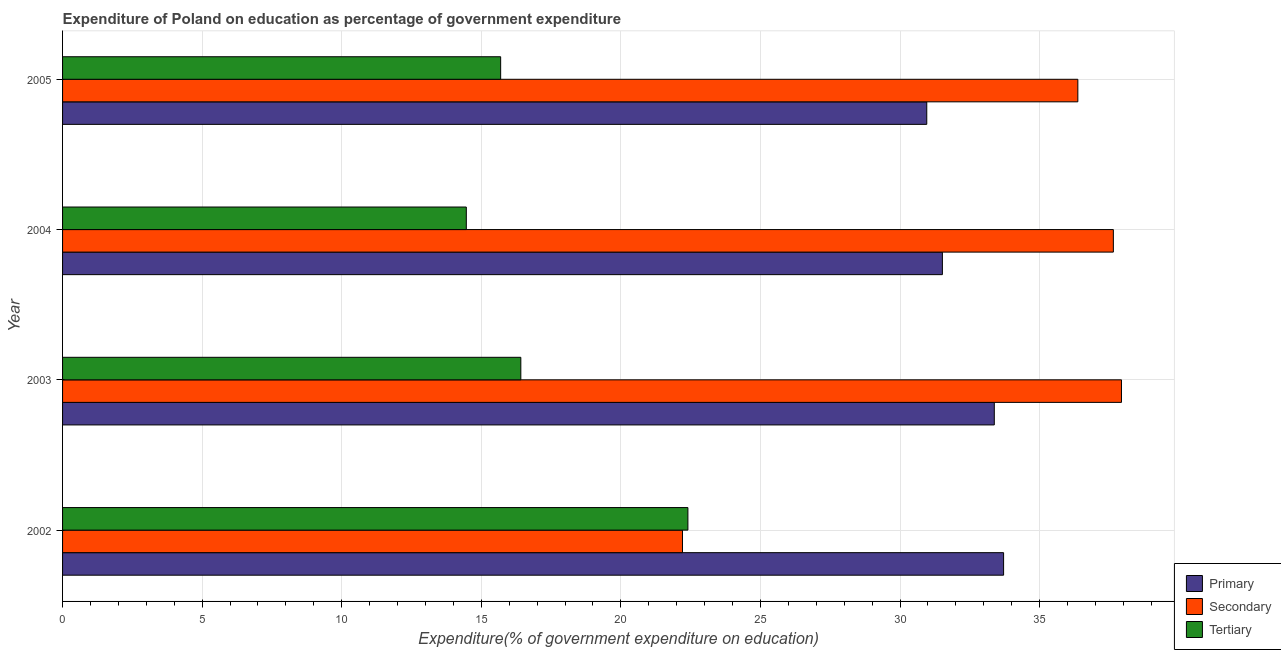How many different coloured bars are there?
Give a very brief answer. 3. How many groups of bars are there?
Ensure brevity in your answer.  4. How many bars are there on the 1st tick from the top?
Keep it short and to the point. 3. In how many cases, is the number of bars for a given year not equal to the number of legend labels?
Offer a very short reply. 0. What is the expenditure on secondary education in 2002?
Your answer should be very brief. 22.21. Across all years, what is the maximum expenditure on primary education?
Provide a short and direct response. 33.71. Across all years, what is the minimum expenditure on primary education?
Your answer should be compact. 30.96. In which year was the expenditure on primary education minimum?
Keep it short and to the point. 2005. What is the total expenditure on secondary education in the graph?
Offer a terse response. 134.15. What is the difference between the expenditure on secondary education in 2003 and that in 2004?
Give a very brief answer. 0.29. What is the difference between the expenditure on tertiary education in 2004 and the expenditure on primary education in 2005?
Your answer should be compact. -16.5. What is the average expenditure on secondary education per year?
Give a very brief answer. 33.54. In the year 2004, what is the difference between the expenditure on primary education and expenditure on tertiary education?
Keep it short and to the point. 17.05. What is the ratio of the expenditure on secondary education in 2002 to that in 2004?
Your answer should be compact. 0.59. What is the difference between the highest and the second highest expenditure on secondary education?
Provide a short and direct response. 0.29. What is the difference between the highest and the lowest expenditure on secondary education?
Provide a short and direct response. 15.73. What does the 1st bar from the top in 2002 represents?
Offer a terse response. Tertiary. What does the 3rd bar from the bottom in 2004 represents?
Keep it short and to the point. Tertiary. Is it the case that in every year, the sum of the expenditure on primary education and expenditure on secondary education is greater than the expenditure on tertiary education?
Keep it short and to the point. Yes. Are all the bars in the graph horizontal?
Provide a succinct answer. Yes. What is the difference between two consecutive major ticks on the X-axis?
Make the answer very short. 5. Does the graph contain grids?
Your answer should be very brief. Yes. Where does the legend appear in the graph?
Offer a terse response. Bottom right. How many legend labels are there?
Make the answer very short. 3. What is the title of the graph?
Your answer should be very brief. Expenditure of Poland on education as percentage of government expenditure. Does "Solid fuel" appear as one of the legend labels in the graph?
Your response must be concise. No. What is the label or title of the X-axis?
Your answer should be compact. Expenditure(% of government expenditure on education). What is the Expenditure(% of government expenditure on education) in Primary in 2002?
Your response must be concise. 33.71. What is the Expenditure(% of government expenditure on education) in Secondary in 2002?
Ensure brevity in your answer.  22.21. What is the Expenditure(% of government expenditure on education) of Tertiary in 2002?
Ensure brevity in your answer.  22.4. What is the Expenditure(% of government expenditure on education) of Primary in 2003?
Ensure brevity in your answer.  33.38. What is the Expenditure(% of government expenditure on education) of Secondary in 2003?
Keep it short and to the point. 37.93. What is the Expenditure(% of government expenditure on education) in Tertiary in 2003?
Offer a very short reply. 16.42. What is the Expenditure(% of government expenditure on education) of Primary in 2004?
Give a very brief answer. 31.52. What is the Expenditure(% of government expenditure on education) in Secondary in 2004?
Offer a terse response. 37.64. What is the Expenditure(% of government expenditure on education) of Tertiary in 2004?
Offer a very short reply. 14.46. What is the Expenditure(% of government expenditure on education) of Primary in 2005?
Make the answer very short. 30.96. What is the Expenditure(% of government expenditure on education) of Secondary in 2005?
Your answer should be very brief. 36.37. What is the Expenditure(% of government expenditure on education) in Tertiary in 2005?
Your answer should be compact. 15.69. Across all years, what is the maximum Expenditure(% of government expenditure on education) of Primary?
Provide a succinct answer. 33.71. Across all years, what is the maximum Expenditure(% of government expenditure on education) in Secondary?
Offer a terse response. 37.93. Across all years, what is the maximum Expenditure(% of government expenditure on education) of Tertiary?
Ensure brevity in your answer.  22.4. Across all years, what is the minimum Expenditure(% of government expenditure on education) in Primary?
Ensure brevity in your answer.  30.96. Across all years, what is the minimum Expenditure(% of government expenditure on education) in Secondary?
Provide a short and direct response. 22.21. Across all years, what is the minimum Expenditure(% of government expenditure on education) of Tertiary?
Ensure brevity in your answer.  14.46. What is the total Expenditure(% of government expenditure on education) in Primary in the graph?
Your response must be concise. 129.57. What is the total Expenditure(% of government expenditure on education) of Secondary in the graph?
Offer a terse response. 134.15. What is the total Expenditure(% of government expenditure on education) in Tertiary in the graph?
Your answer should be very brief. 68.98. What is the difference between the Expenditure(% of government expenditure on education) of Primary in 2002 and that in 2003?
Offer a very short reply. 0.33. What is the difference between the Expenditure(% of government expenditure on education) of Secondary in 2002 and that in 2003?
Your answer should be very brief. -15.73. What is the difference between the Expenditure(% of government expenditure on education) of Tertiary in 2002 and that in 2003?
Make the answer very short. 5.99. What is the difference between the Expenditure(% of government expenditure on education) in Primary in 2002 and that in 2004?
Your answer should be compact. 2.19. What is the difference between the Expenditure(% of government expenditure on education) of Secondary in 2002 and that in 2004?
Provide a succinct answer. -15.44. What is the difference between the Expenditure(% of government expenditure on education) of Tertiary in 2002 and that in 2004?
Provide a short and direct response. 7.94. What is the difference between the Expenditure(% of government expenditure on education) in Primary in 2002 and that in 2005?
Your answer should be very brief. 2.75. What is the difference between the Expenditure(% of government expenditure on education) in Secondary in 2002 and that in 2005?
Offer a very short reply. -14.16. What is the difference between the Expenditure(% of government expenditure on education) in Tertiary in 2002 and that in 2005?
Your answer should be very brief. 6.71. What is the difference between the Expenditure(% of government expenditure on education) in Primary in 2003 and that in 2004?
Your response must be concise. 1.86. What is the difference between the Expenditure(% of government expenditure on education) in Secondary in 2003 and that in 2004?
Ensure brevity in your answer.  0.29. What is the difference between the Expenditure(% of government expenditure on education) in Tertiary in 2003 and that in 2004?
Your response must be concise. 1.95. What is the difference between the Expenditure(% of government expenditure on education) in Primary in 2003 and that in 2005?
Keep it short and to the point. 2.42. What is the difference between the Expenditure(% of government expenditure on education) of Secondary in 2003 and that in 2005?
Provide a short and direct response. 1.56. What is the difference between the Expenditure(% of government expenditure on education) in Tertiary in 2003 and that in 2005?
Provide a short and direct response. 0.72. What is the difference between the Expenditure(% of government expenditure on education) of Primary in 2004 and that in 2005?
Ensure brevity in your answer.  0.56. What is the difference between the Expenditure(% of government expenditure on education) of Secondary in 2004 and that in 2005?
Provide a short and direct response. 1.27. What is the difference between the Expenditure(% of government expenditure on education) of Tertiary in 2004 and that in 2005?
Offer a terse response. -1.23. What is the difference between the Expenditure(% of government expenditure on education) in Primary in 2002 and the Expenditure(% of government expenditure on education) in Secondary in 2003?
Offer a very short reply. -4.22. What is the difference between the Expenditure(% of government expenditure on education) in Primary in 2002 and the Expenditure(% of government expenditure on education) in Tertiary in 2003?
Your response must be concise. 17.29. What is the difference between the Expenditure(% of government expenditure on education) of Secondary in 2002 and the Expenditure(% of government expenditure on education) of Tertiary in 2003?
Your answer should be compact. 5.79. What is the difference between the Expenditure(% of government expenditure on education) in Primary in 2002 and the Expenditure(% of government expenditure on education) in Secondary in 2004?
Provide a succinct answer. -3.93. What is the difference between the Expenditure(% of government expenditure on education) of Primary in 2002 and the Expenditure(% of government expenditure on education) of Tertiary in 2004?
Offer a very short reply. 19.25. What is the difference between the Expenditure(% of government expenditure on education) of Secondary in 2002 and the Expenditure(% of government expenditure on education) of Tertiary in 2004?
Give a very brief answer. 7.74. What is the difference between the Expenditure(% of government expenditure on education) in Primary in 2002 and the Expenditure(% of government expenditure on education) in Secondary in 2005?
Ensure brevity in your answer.  -2.66. What is the difference between the Expenditure(% of government expenditure on education) in Primary in 2002 and the Expenditure(% of government expenditure on education) in Tertiary in 2005?
Your answer should be very brief. 18.02. What is the difference between the Expenditure(% of government expenditure on education) of Secondary in 2002 and the Expenditure(% of government expenditure on education) of Tertiary in 2005?
Your response must be concise. 6.51. What is the difference between the Expenditure(% of government expenditure on education) in Primary in 2003 and the Expenditure(% of government expenditure on education) in Secondary in 2004?
Provide a succinct answer. -4.26. What is the difference between the Expenditure(% of government expenditure on education) of Primary in 2003 and the Expenditure(% of government expenditure on education) of Tertiary in 2004?
Offer a very short reply. 18.91. What is the difference between the Expenditure(% of government expenditure on education) of Secondary in 2003 and the Expenditure(% of government expenditure on education) of Tertiary in 2004?
Offer a terse response. 23.47. What is the difference between the Expenditure(% of government expenditure on education) in Primary in 2003 and the Expenditure(% of government expenditure on education) in Secondary in 2005?
Ensure brevity in your answer.  -2.99. What is the difference between the Expenditure(% of government expenditure on education) of Primary in 2003 and the Expenditure(% of government expenditure on education) of Tertiary in 2005?
Offer a very short reply. 17.68. What is the difference between the Expenditure(% of government expenditure on education) of Secondary in 2003 and the Expenditure(% of government expenditure on education) of Tertiary in 2005?
Ensure brevity in your answer.  22.24. What is the difference between the Expenditure(% of government expenditure on education) of Primary in 2004 and the Expenditure(% of government expenditure on education) of Secondary in 2005?
Give a very brief answer. -4.85. What is the difference between the Expenditure(% of government expenditure on education) in Primary in 2004 and the Expenditure(% of government expenditure on education) in Tertiary in 2005?
Your answer should be very brief. 15.82. What is the difference between the Expenditure(% of government expenditure on education) in Secondary in 2004 and the Expenditure(% of government expenditure on education) in Tertiary in 2005?
Your answer should be compact. 21.95. What is the average Expenditure(% of government expenditure on education) of Primary per year?
Make the answer very short. 32.39. What is the average Expenditure(% of government expenditure on education) of Secondary per year?
Give a very brief answer. 33.54. What is the average Expenditure(% of government expenditure on education) in Tertiary per year?
Ensure brevity in your answer.  17.24. In the year 2002, what is the difference between the Expenditure(% of government expenditure on education) of Primary and Expenditure(% of government expenditure on education) of Secondary?
Provide a short and direct response. 11.5. In the year 2002, what is the difference between the Expenditure(% of government expenditure on education) of Primary and Expenditure(% of government expenditure on education) of Tertiary?
Your answer should be compact. 11.31. In the year 2002, what is the difference between the Expenditure(% of government expenditure on education) in Secondary and Expenditure(% of government expenditure on education) in Tertiary?
Keep it short and to the point. -0.19. In the year 2003, what is the difference between the Expenditure(% of government expenditure on education) of Primary and Expenditure(% of government expenditure on education) of Secondary?
Your answer should be very brief. -4.56. In the year 2003, what is the difference between the Expenditure(% of government expenditure on education) of Primary and Expenditure(% of government expenditure on education) of Tertiary?
Make the answer very short. 16.96. In the year 2003, what is the difference between the Expenditure(% of government expenditure on education) of Secondary and Expenditure(% of government expenditure on education) of Tertiary?
Offer a terse response. 21.52. In the year 2004, what is the difference between the Expenditure(% of government expenditure on education) in Primary and Expenditure(% of government expenditure on education) in Secondary?
Provide a succinct answer. -6.12. In the year 2004, what is the difference between the Expenditure(% of government expenditure on education) of Primary and Expenditure(% of government expenditure on education) of Tertiary?
Keep it short and to the point. 17.05. In the year 2004, what is the difference between the Expenditure(% of government expenditure on education) in Secondary and Expenditure(% of government expenditure on education) in Tertiary?
Ensure brevity in your answer.  23.18. In the year 2005, what is the difference between the Expenditure(% of government expenditure on education) of Primary and Expenditure(% of government expenditure on education) of Secondary?
Give a very brief answer. -5.41. In the year 2005, what is the difference between the Expenditure(% of government expenditure on education) in Primary and Expenditure(% of government expenditure on education) in Tertiary?
Make the answer very short. 15.26. In the year 2005, what is the difference between the Expenditure(% of government expenditure on education) in Secondary and Expenditure(% of government expenditure on education) in Tertiary?
Ensure brevity in your answer.  20.68. What is the ratio of the Expenditure(% of government expenditure on education) of Secondary in 2002 to that in 2003?
Ensure brevity in your answer.  0.59. What is the ratio of the Expenditure(% of government expenditure on education) of Tertiary in 2002 to that in 2003?
Keep it short and to the point. 1.36. What is the ratio of the Expenditure(% of government expenditure on education) of Primary in 2002 to that in 2004?
Give a very brief answer. 1.07. What is the ratio of the Expenditure(% of government expenditure on education) of Secondary in 2002 to that in 2004?
Your answer should be compact. 0.59. What is the ratio of the Expenditure(% of government expenditure on education) of Tertiary in 2002 to that in 2004?
Offer a terse response. 1.55. What is the ratio of the Expenditure(% of government expenditure on education) in Primary in 2002 to that in 2005?
Keep it short and to the point. 1.09. What is the ratio of the Expenditure(% of government expenditure on education) in Secondary in 2002 to that in 2005?
Offer a terse response. 0.61. What is the ratio of the Expenditure(% of government expenditure on education) of Tertiary in 2002 to that in 2005?
Keep it short and to the point. 1.43. What is the ratio of the Expenditure(% of government expenditure on education) in Primary in 2003 to that in 2004?
Provide a short and direct response. 1.06. What is the ratio of the Expenditure(% of government expenditure on education) of Secondary in 2003 to that in 2004?
Your answer should be very brief. 1.01. What is the ratio of the Expenditure(% of government expenditure on education) of Tertiary in 2003 to that in 2004?
Offer a very short reply. 1.14. What is the ratio of the Expenditure(% of government expenditure on education) of Primary in 2003 to that in 2005?
Provide a succinct answer. 1.08. What is the ratio of the Expenditure(% of government expenditure on education) in Secondary in 2003 to that in 2005?
Give a very brief answer. 1.04. What is the ratio of the Expenditure(% of government expenditure on education) of Tertiary in 2003 to that in 2005?
Keep it short and to the point. 1.05. What is the ratio of the Expenditure(% of government expenditure on education) in Primary in 2004 to that in 2005?
Give a very brief answer. 1.02. What is the ratio of the Expenditure(% of government expenditure on education) of Secondary in 2004 to that in 2005?
Your answer should be compact. 1.03. What is the ratio of the Expenditure(% of government expenditure on education) of Tertiary in 2004 to that in 2005?
Provide a short and direct response. 0.92. What is the difference between the highest and the second highest Expenditure(% of government expenditure on education) in Primary?
Your response must be concise. 0.33. What is the difference between the highest and the second highest Expenditure(% of government expenditure on education) of Secondary?
Offer a terse response. 0.29. What is the difference between the highest and the second highest Expenditure(% of government expenditure on education) of Tertiary?
Your answer should be compact. 5.99. What is the difference between the highest and the lowest Expenditure(% of government expenditure on education) of Primary?
Make the answer very short. 2.75. What is the difference between the highest and the lowest Expenditure(% of government expenditure on education) of Secondary?
Your response must be concise. 15.73. What is the difference between the highest and the lowest Expenditure(% of government expenditure on education) in Tertiary?
Your answer should be compact. 7.94. 